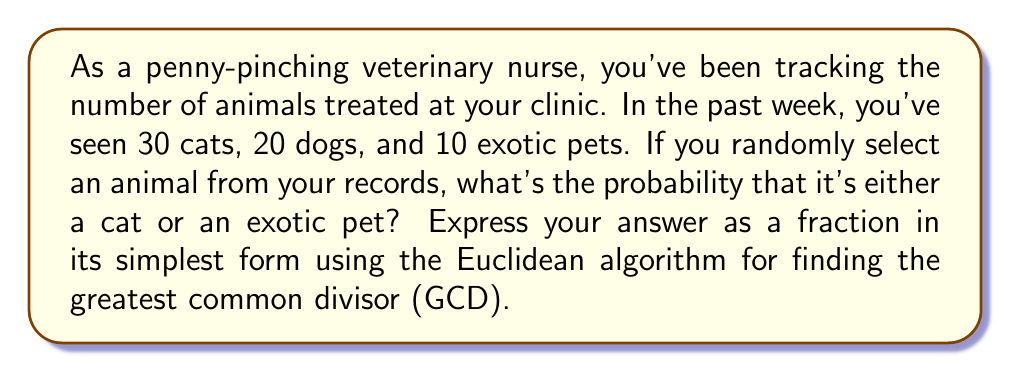Give your solution to this math problem. Let's approach this step-by-step:

1) First, we need to calculate the total number of animals treated:
   $30 + 20 + 10 = 60$ total animals

2) Now, we need to find the number of favorable outcomes (cats or exotic pets):
   $30 + 10 = 40$ cats and exotic pets

3) The probability is the number of favorable outcomes divided by the total number of possible outcomes:
   $\frac{40}{60}$

4) To simplify this fraction, we need to find the GCD of 40 and 60 using the Euclidean algorithm:

   $60 = 1 \times 40 + 20$
   $40 = 2 \times 20 + 0$

   The GCD is 20.

5) Divide both the numerator and denominator by the GCD:
   $\frac{40 \div 20}{60 \div 20} = \frac{2}{3}$

Therefore, the probability of selecting either a cat or an exotic pet is $\frac{2}{3}$.
Answer: $\frac{2}{3}$ 